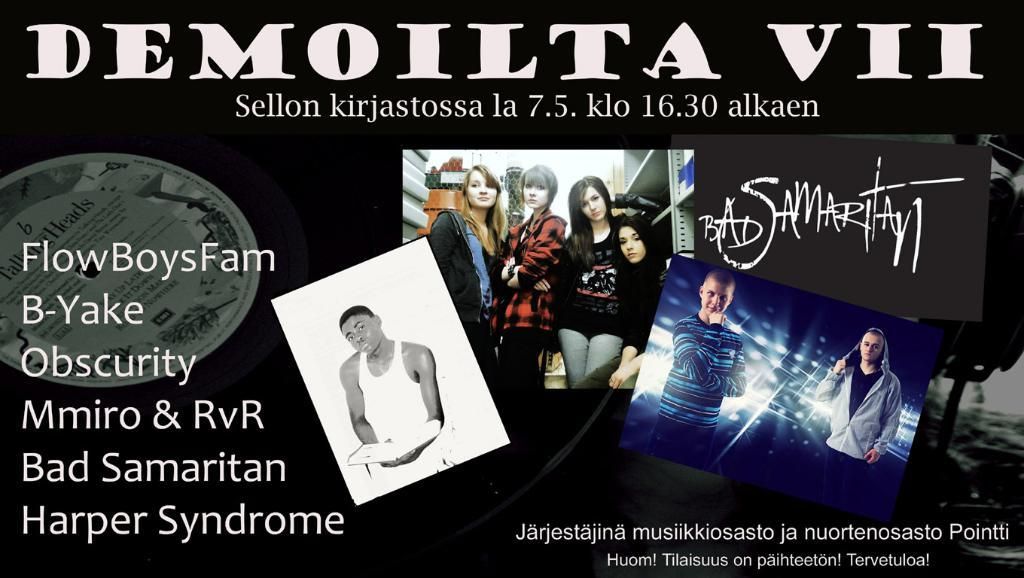Provide a one-sentence caption for the provided image. A poster or ad for Demoilta VII with pictures of different bands. 